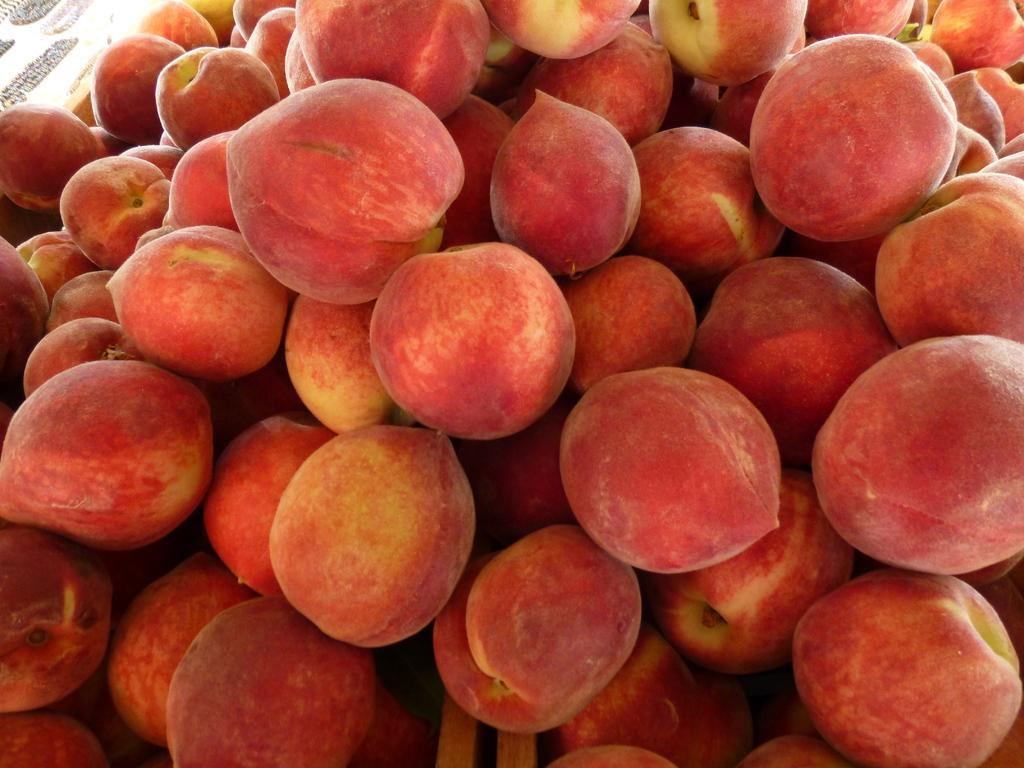What type of fruit is present in the image? There are many apples in the image. What color are the apples in the image? The apples are red in color. How does the bait attract fish in the image? There is no bait or fish present in the image; it only features apples. 